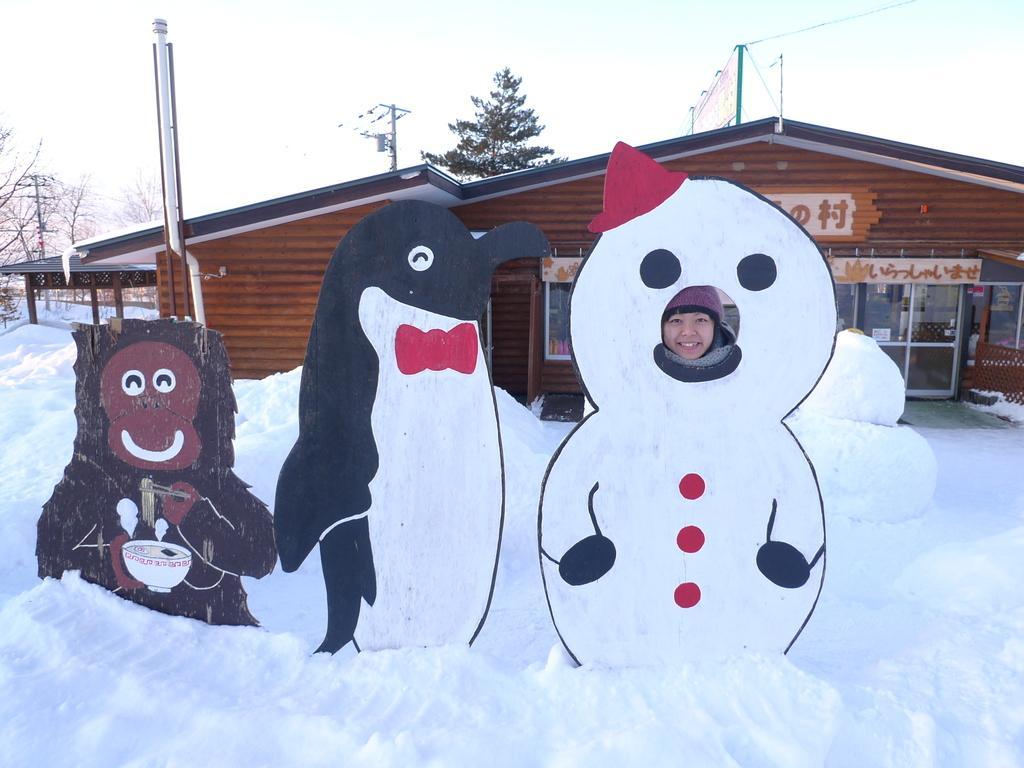How would you summarize this image in a sentence or two? In the image there are three structures and there is a person behind the structure of snowman and around the structures there is a lot of ice, behind the ice there is a cafe, in the background there are some trees. 